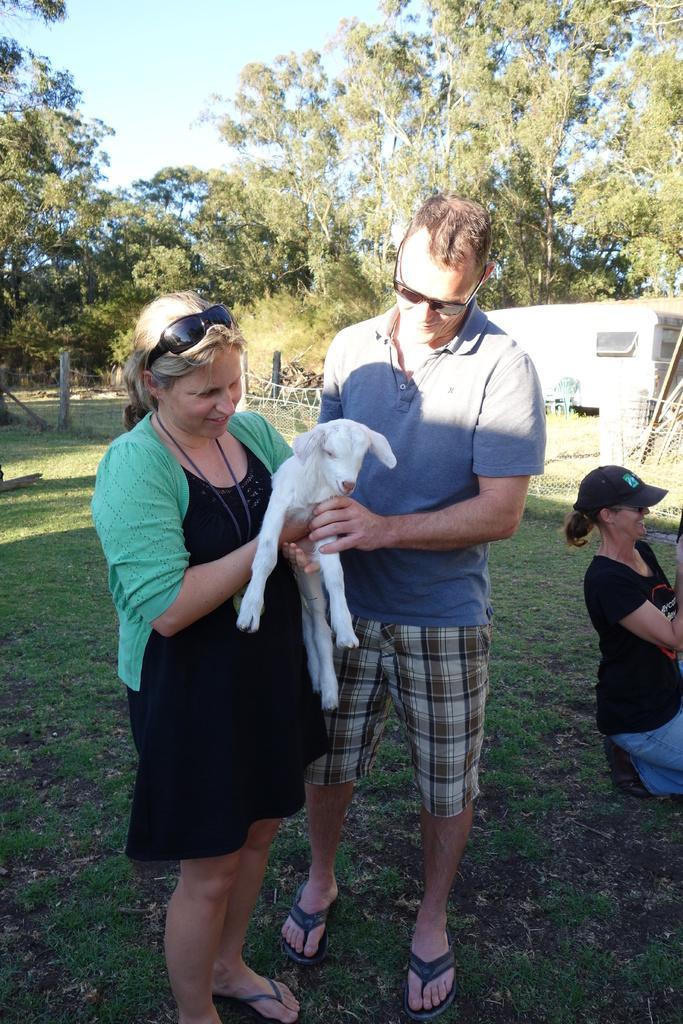Could you give a brief overview of what you see in this image? In this image we can see a group of people standing on the grass field. One woman is holding an animal in her hands. On the right side of the image we can see a fence, chair and a vehicle parked on the ground. In the background, we can see some poles, group of trees. At the top of the image we can see the sky. 